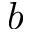<formula> <loc_0><loc_0><loc_500><loc_500>b</formula> 